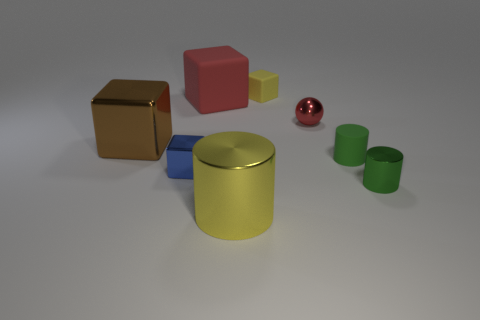Can you tell which object is the largest? The largest object appears to be the yellow cylinder in the center of the image based on its dimensions relative to the other objects. 